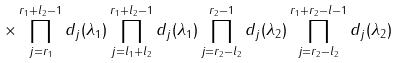<formula> <loc_0><loc_0><loc_500><loc_500>\times \prod _ { j = r _ { 1 } } ^ { r _ { 1 } + l _ { 2 } - 1 } d _ { j } ( \lambda _ { 1 } ) \prod _ { j = l _ { 1 } + l _ { 2 } } ^ { r _ { 1 } + l _ { 2 } - 1 } d _ { j } ( \lambda _ { 1 } ) \prod _ { j = r _ { 2 } - l _ { 2 } } ^ { r _ { 2 } - 1 } d _ { j } ( \lambda _ { 2 } ) \prod _ { j = r _ { 2 } - l _ { 2 } } ^ { r _ { 1 } + r _ { 2 } - l - 1 } d _ { j } ( \lambda _ { 2 } )</formula> 